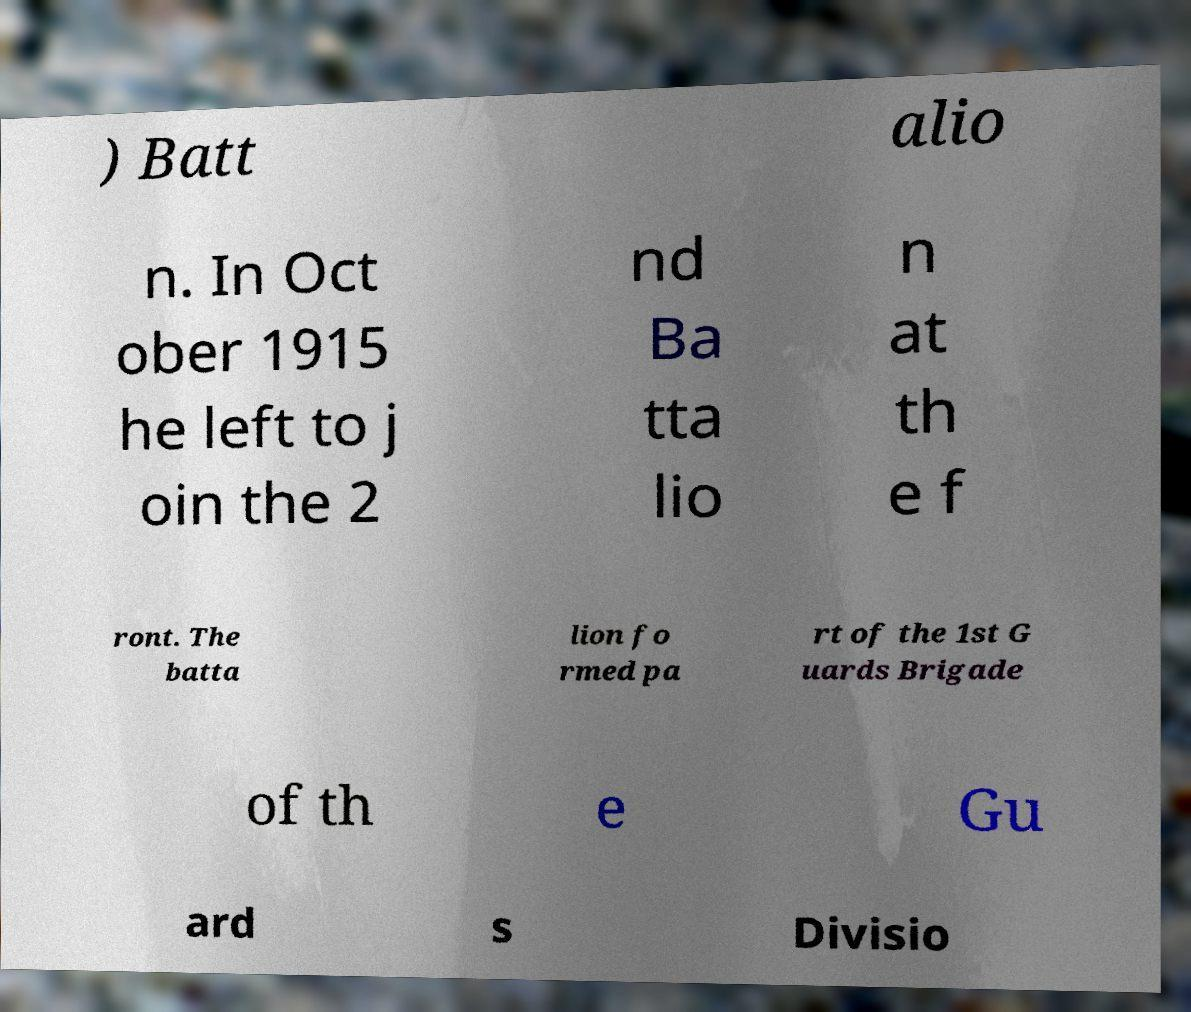What messages or text are displayed in this image? I need them in a readable, typed format. ) Batt alio n. In Oct ober 1915 he left to j oin the 2 nd Ba tta lio n at th e f ront. The batta lion fo rmed pa rt of the 1st G uards Brigade of th e Gu ard s Divisio 